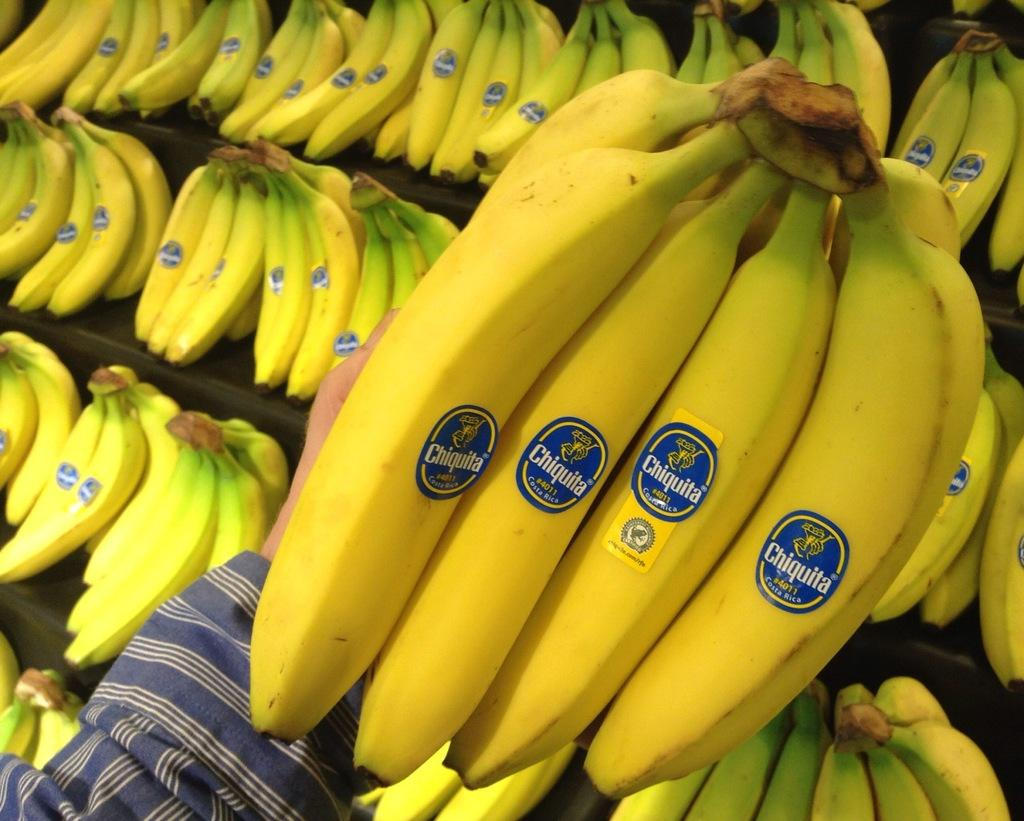What type of fruit is visible in the image? There are bananas in the image. Are there any additional features on the bananas? Yes, the bananas have stickers on them. Who is holding the bananas in the image? Someone is holding the bananas in their hand. What type of acoustics can be heard from the bananas in the image? There is no sound or acoustics associated with the bananas in the image. What type of skin is visible on the person holding the bananas? The image does not provide enough detail to determine the skin type of the person holding the bananas. 